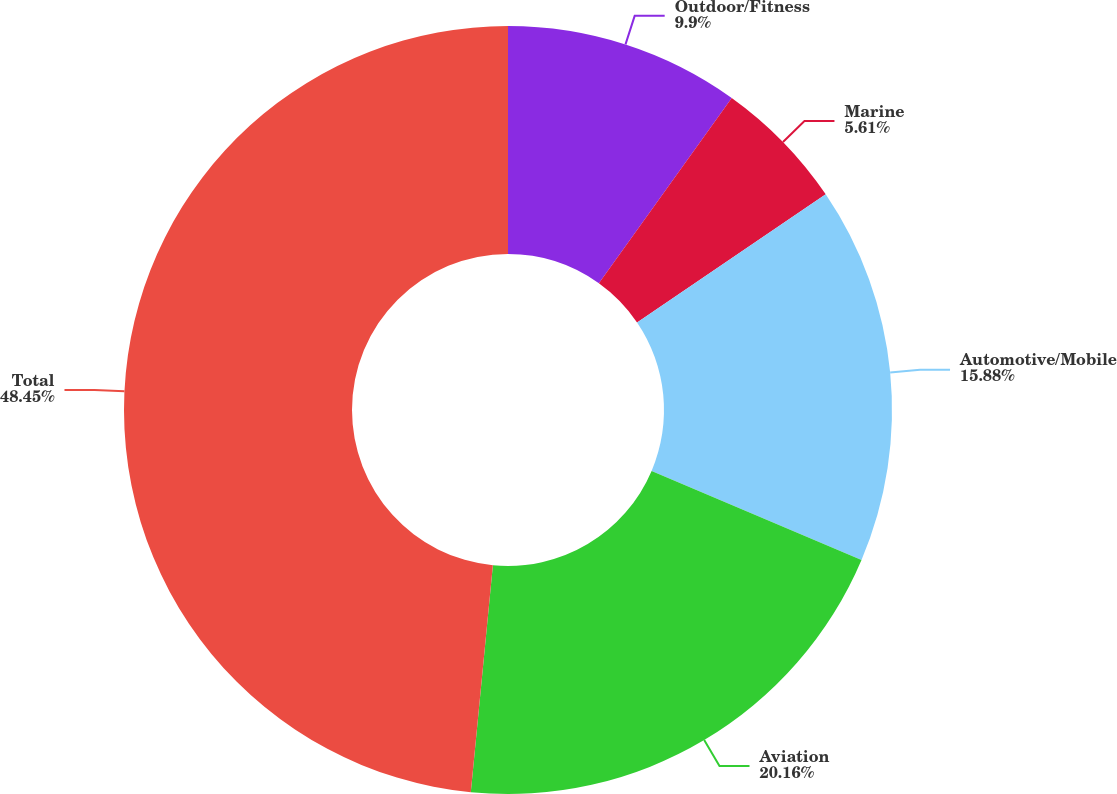<chart> <loc_0><loc_0><loc_500><loc_500><pie_chart><fcel>Outdoor/Fitness<fcel>Marine<fcel>Automotive/Mobile<fcel>Aviation<fcel>Total<nl><fcel>9.9%<fcel>5.61%<fcel>15.88%<fcel>20.16%<fcel>48.46%<nl></chart> 